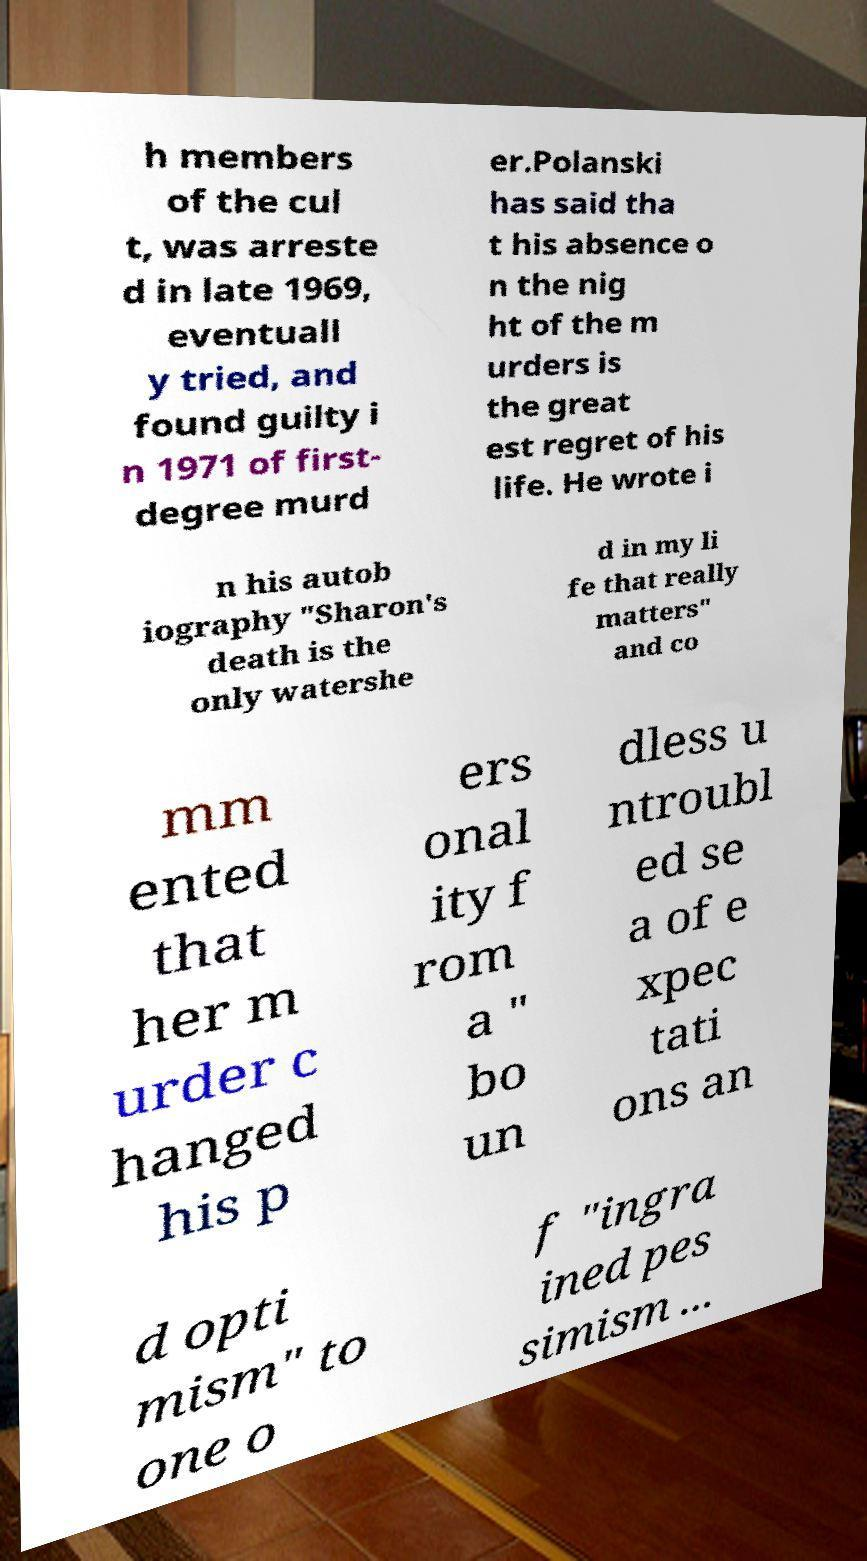Could you assist in decoding the text presented in this image and type it out clearly? h members of the cul t, was arreste d in late 1969, eventuall y tried, and found guilty i n 1971 of first- degree murd er.Polanski has said tha t his absence o n the nig ht of the m urders is the great est regret of his life. He wrote i n his autob iography "Sharon's death is the only watershe d in my li fe that really matters" and co mm ented that her m urder c hanged his p ers onal ity f rom a " bo un dless u ntroubl ed se a of e xpec tati ons an d opti mism" to one o f "ingra ined pes simism ... 